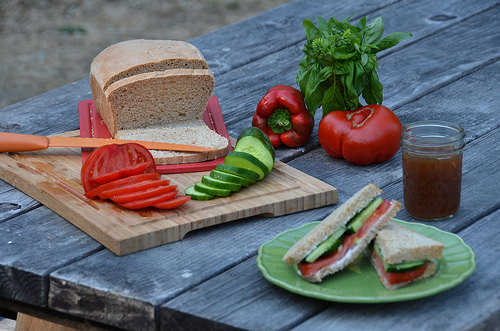<image>
Is there a knife on the bread? Yes. Looking at the image, I can see the knife is positioned on top of the bread, with the bread providing support. Where is the food in relation to the plate? Is it on the plate? No. The food is not positioned on the plate. They may be near each other, but the food is not supported by or resting on top of the plate. 